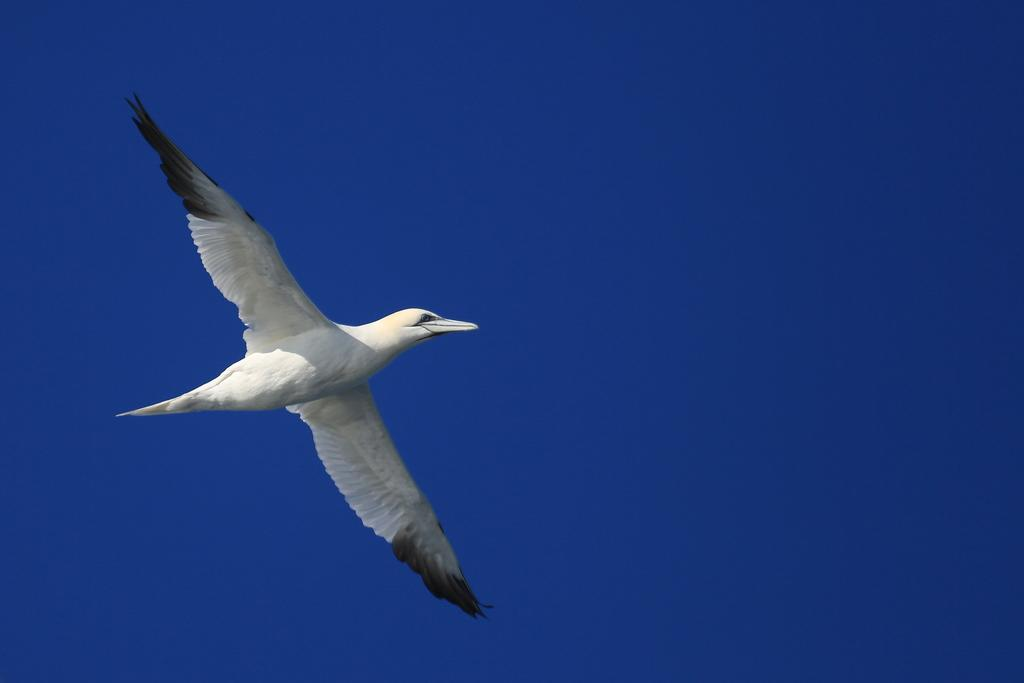What type of animal can be seen in the image? There is a bird in the image. What is the bird doing in the image? The bird is flying in the sky. Where is the sheep located in the image? There is no sheep present in the image; it only features a bird flying in the sky. What type of egg can be seen in the image? There is no egg present in the image; it only features a bird flying in the sky. 